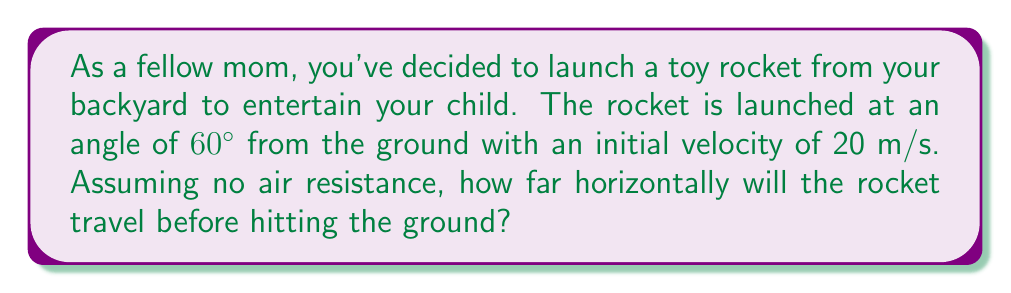Help me with this question. Let's approach this step-by-step using the equations of motion for projectile motion:

1) First, we need to break down the initial velocity into its horizontal and vertical components:

   $v_{0x} = v_0 \cos \theta = 20 \cos 60° = 10$ m/s
   $v_{0y} = v_0 \sin \theta = 20 \sin 60° = 17.32$ m/s

2) The time of flight can be calculated using the vertical motion equation:

   $y = v_{0y}t - \frac{1}{2}gt^2$

   At the highest point, $y = 0$:

   $0 = 17.32t - \frac{1}{2}(9.8)t^2$

3) Solving this quadratic equation:

   $t = \frac{2v_{0y}}{g} = \frac{2(17.32)}{9.8} = 3.54$ seconds

   This is the time to reach the highest point. The total time of flight is twice this:

   $t_{total} = 2(3.54) = 7.08$ seconds

4) Now, we can use the horizontal motion equation to find the distance:

   $x = v_{0x}t$

   $x = 10 * 7.08 = 70.8$ meters

Therefore, the rocket will travel 70.8 meters horizontally before hitting the ground.
Answer: 70.8 meters 